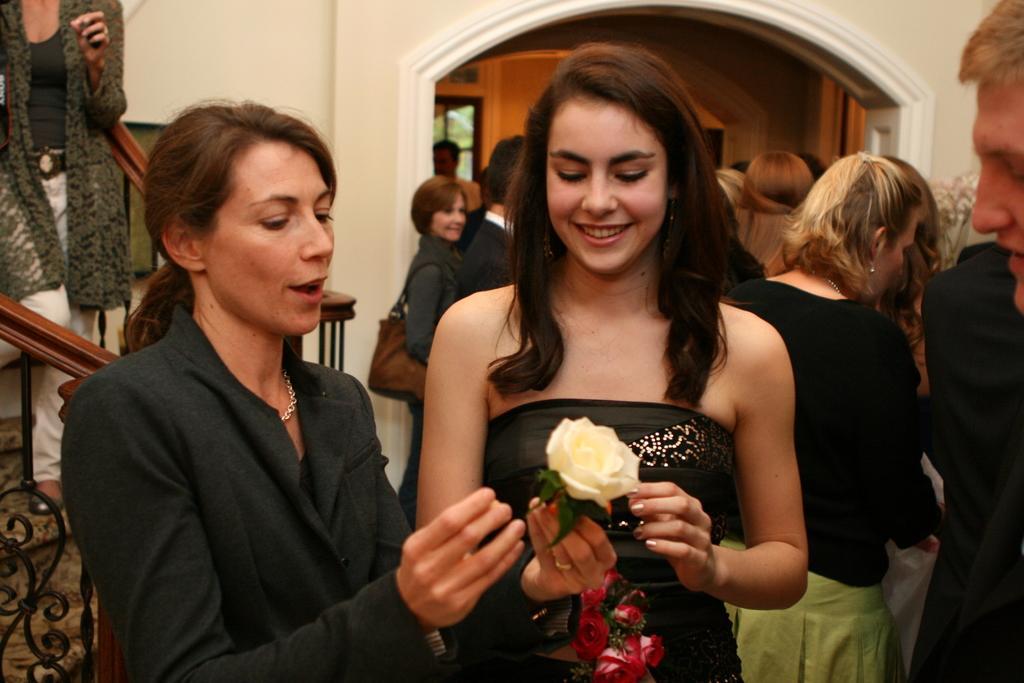How would you summarize this image in a sentence or two? This image consists of two women standing in the front. On the left, the woman wearing a black jacket is holding a flowers. On the left, we can see the stairs. In the background, there are many people and there is a wall. 